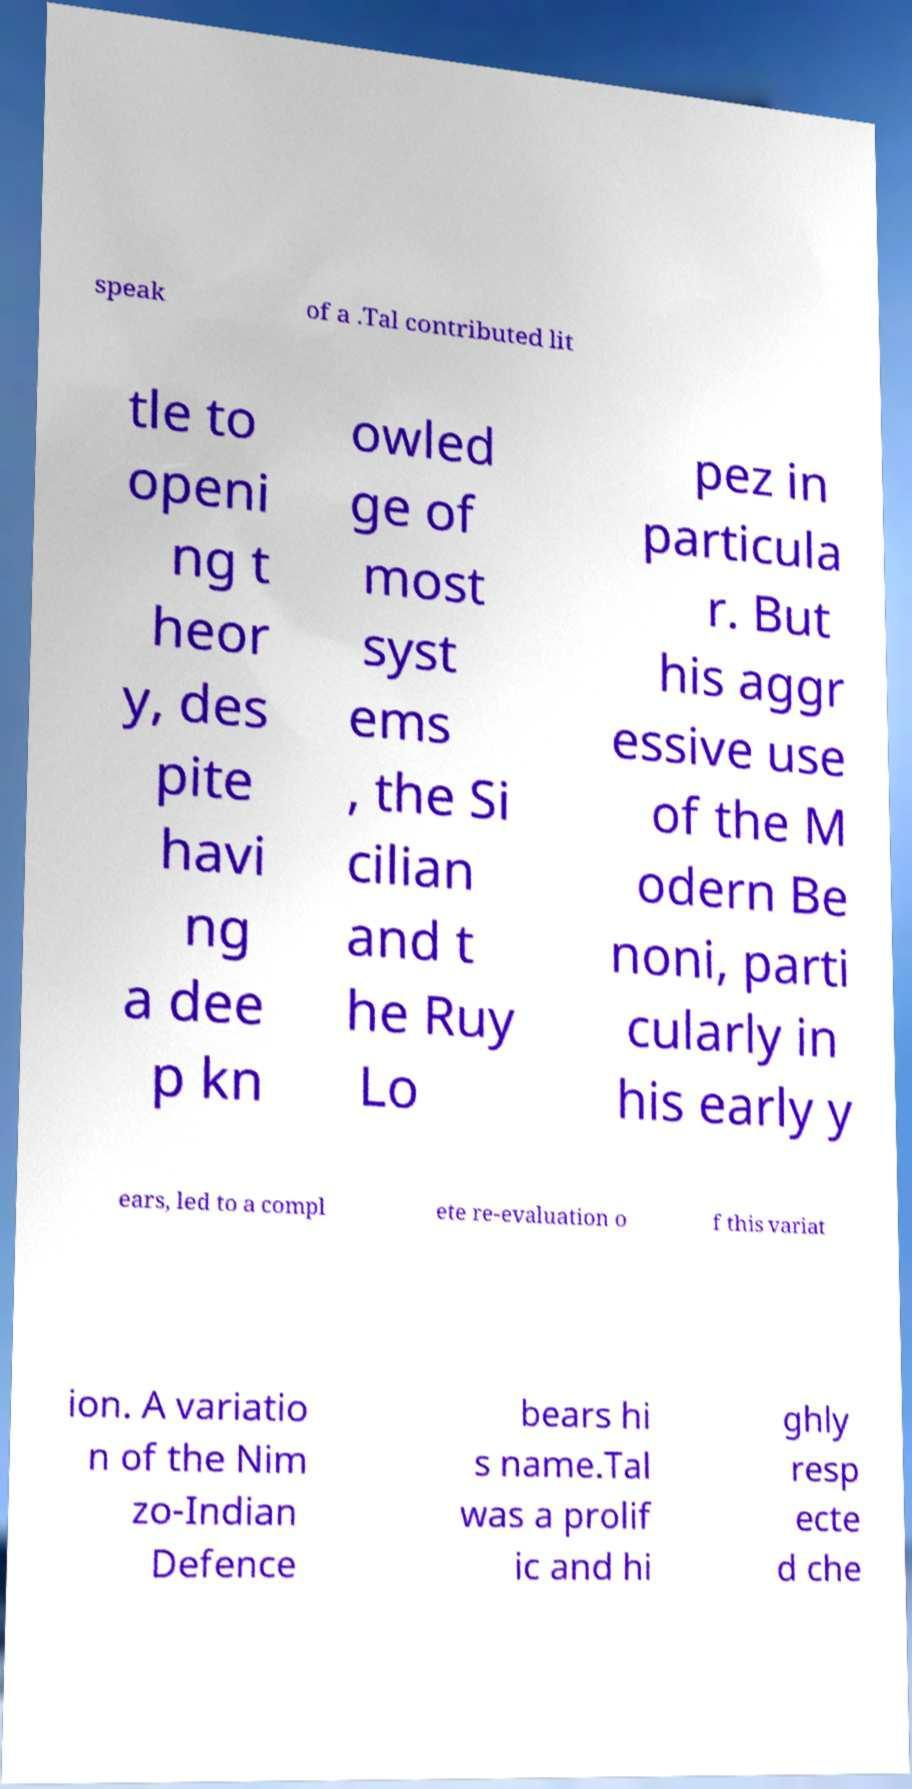Can you accurately transcribe the text from the provided image for me? speak of a .Tal contributed lit tle to openi ng t heor y, des pite havi ng a dee p kn owled ge of most syst ems , the Si cilian and t he Ruy Lo pez in particula r. But his aggr essive use of the M odern Be noni, parti cularly in his early y ears, led to a compl ete re-evaluation o f this variat ion. A variatio n of the Nim zo-Indian Defence bears hi s name.Tal was a prolif ic and hi ghly resp ecte d che 